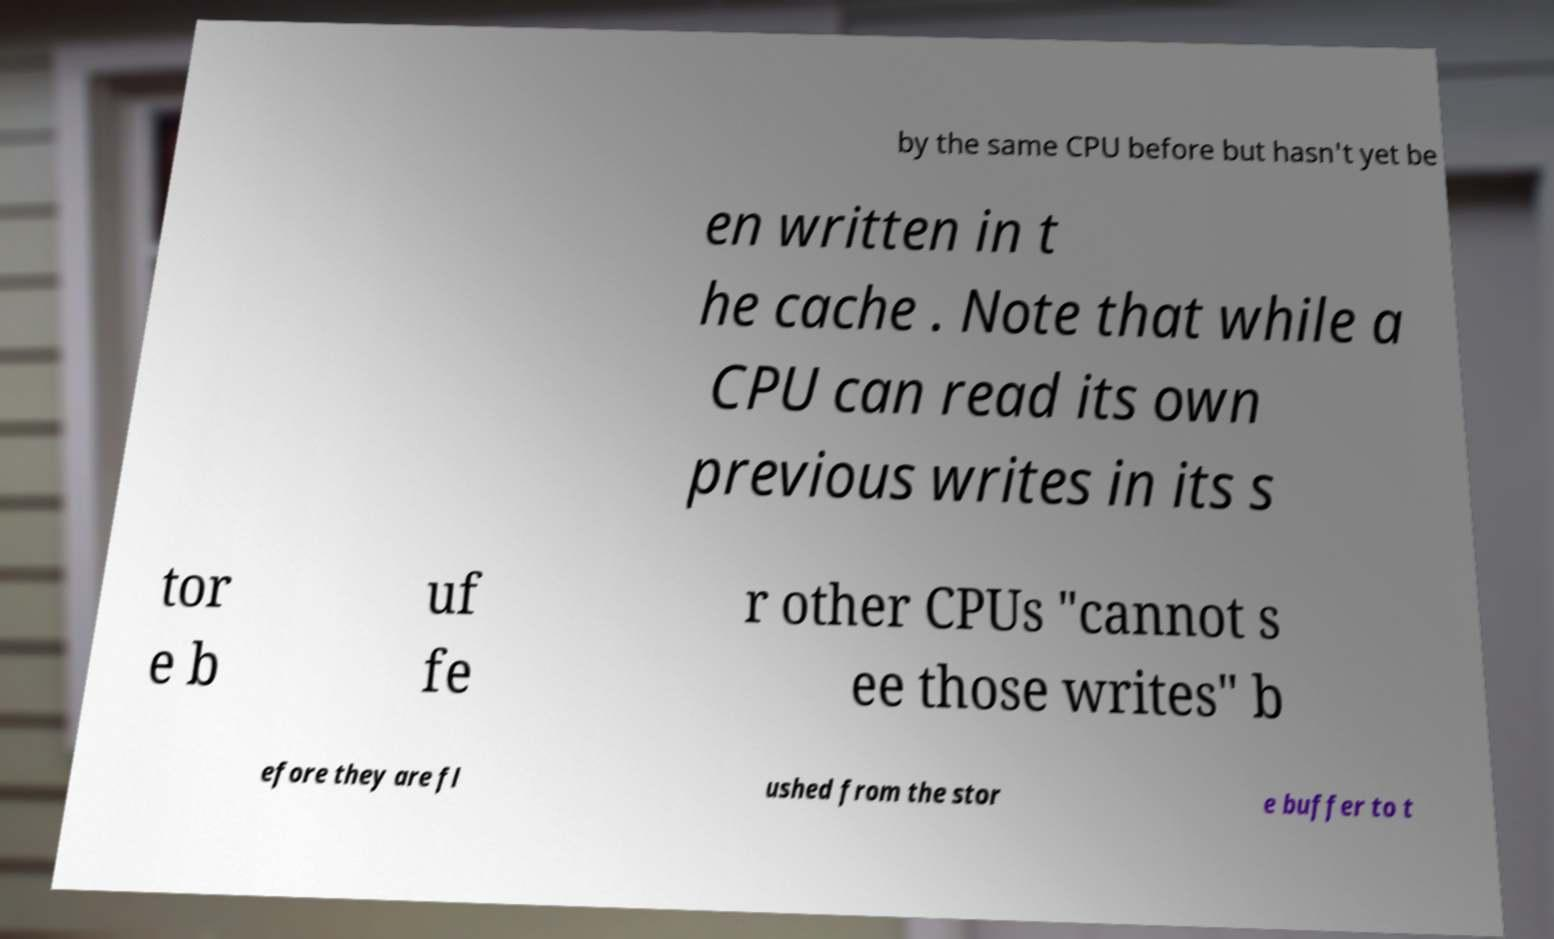Can you read and provide the text displayed in the image?This photo seems to have some interesting text. Can you extract and type it out for me? by the same CPU before but hasn't yet be en written in t he cache . Note that while a CPU can read its own previous writes in its s tor e b uf fe r other CPUs "cannot s ee those writes" b efore they are fl ushed from the stor e buffer to t 